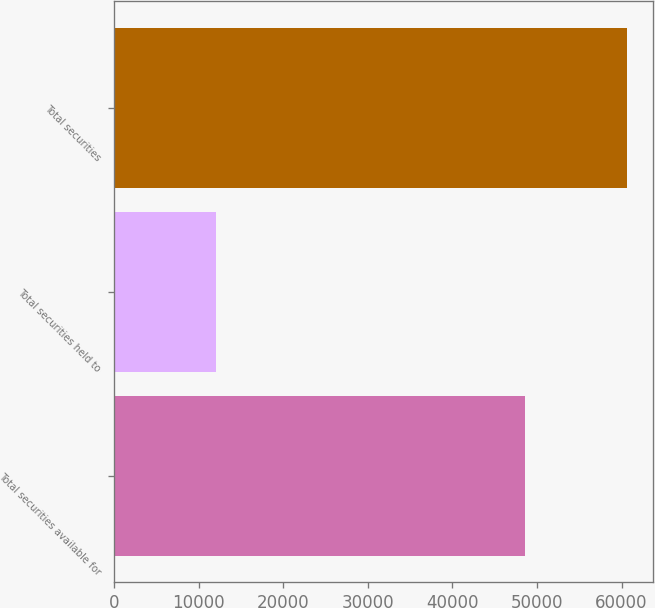<chart> <loc_0><loc_0><loc_500><loc_500><bar_chart><fcel>Total securities available for<fcel>Total securities held to<fcel>Total securities<nl><fcel>48609<fcel>12066<fcel>60675<nl></chart> 